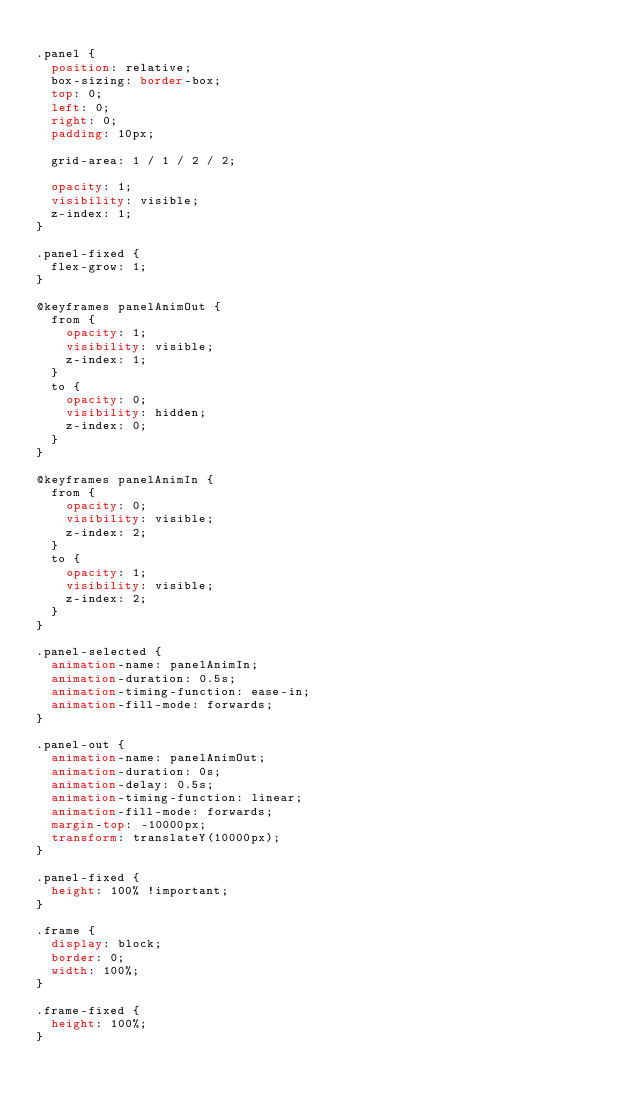Convert code to text. <code><loc_0><loc_0><loc_500><loc_500><_CSS_>
.panel {
  position: relative;
  box-sizing: border-box;
  top: 0;
  left: 0;
  right: 0;
  padding: 10px;

  grid-area: 1 / 1 / 2 / 2;

  opacity: 1;
  visibility: visible;
  z-index: 1;
}

.panel-fixed {
  flex-grow: 1;
}

@keyframes panelAnimOut {
  from {
    opacity: 1;
    visibility: visible;
    z-index: 1;
  }
  to {
    opacity: 0;
    visibility: hidden;
    z-index: 0;
  }
}

@keyframes panelAnimIn {
  from {
    opacity: 0;
    visibility: visible;
    z-index: 2;
  }
  to {
    opacity: 1;
    visibility: visible;
    z-index: 2;
  }
}

.panel-selected {
  animation-name: panelAnimIn;
  animation-duration: 0.5s;
  animation-timing-function: ease-in;
  animation-fill-mode: forwards;
}

.panel-out {
  animation-name: panelAnimOut;
  animation-duration: 0s;
  animation-delay: 0.5s;
  animation-timing-function: linear;
  animation-fill-mode: forwards;
  margin-top: -10000px;
  transform: translateY(10000px);
}

.panel-fixed {
  height: 100% !important;
}

.frame {
  display: block;
  border: 0;
  width: 100%;
}

.frame-fixed {
  height: 100%;
}
</code> 